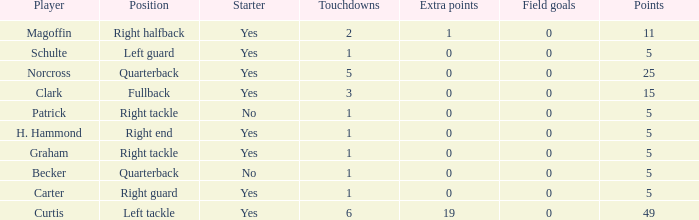Name the number of field goals for 19 extra points 1.0. 